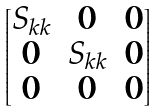<formula> <loc_0><loc_0><loc_500><loc_500>\begin{bmatrix} S _ { k k } & 0 & 0 \\ 0 & S _ { k k } & 0 \\ 0 & 0 & 0 \end{bmatrix}</formula> 